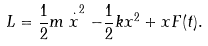<formula> <loc_0><loc_0><loc_500><loc_500>L = \frac { 1 } { 2 } m \stackrel { \cdot } { x } ^ { 2 } - \frac { 1 } { 2 } k x ^ { 2 } + x F ( t ) .</formula> 